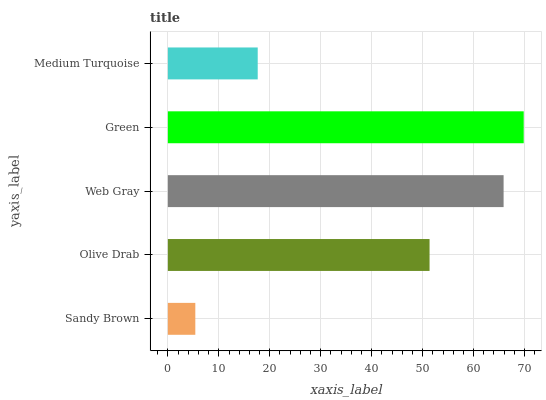Is Sandy Brown the minimum?
Answer yes or no. Yes. Is Green the maximum?
Answer yes or no. Yes. Is Olive Drab the minimum?
Answer yes or no. No. Is Olive Drab the maximum?
Answer yes or no. No. Is Olive Drab greater than Sandy Brown?
Answer yes or no. Yes. Is Sandy Brown less than Olive Drab?
Answer yes or no. Yes. Is Sandy Brown greater than Olive Drab?
Answer yes or no. No. Is Olive Drab less than Sandy Brown?
Answer yes or no. No. Is Olive Drab the high median?
Answer yes or no. Yes. Is Olive Drab the low median?
Answer yes or no. Yes. Is Sandy Brown the high median?
Answer yes or no. No. Is Web Gray the low median?
Answer yes or no. No. 